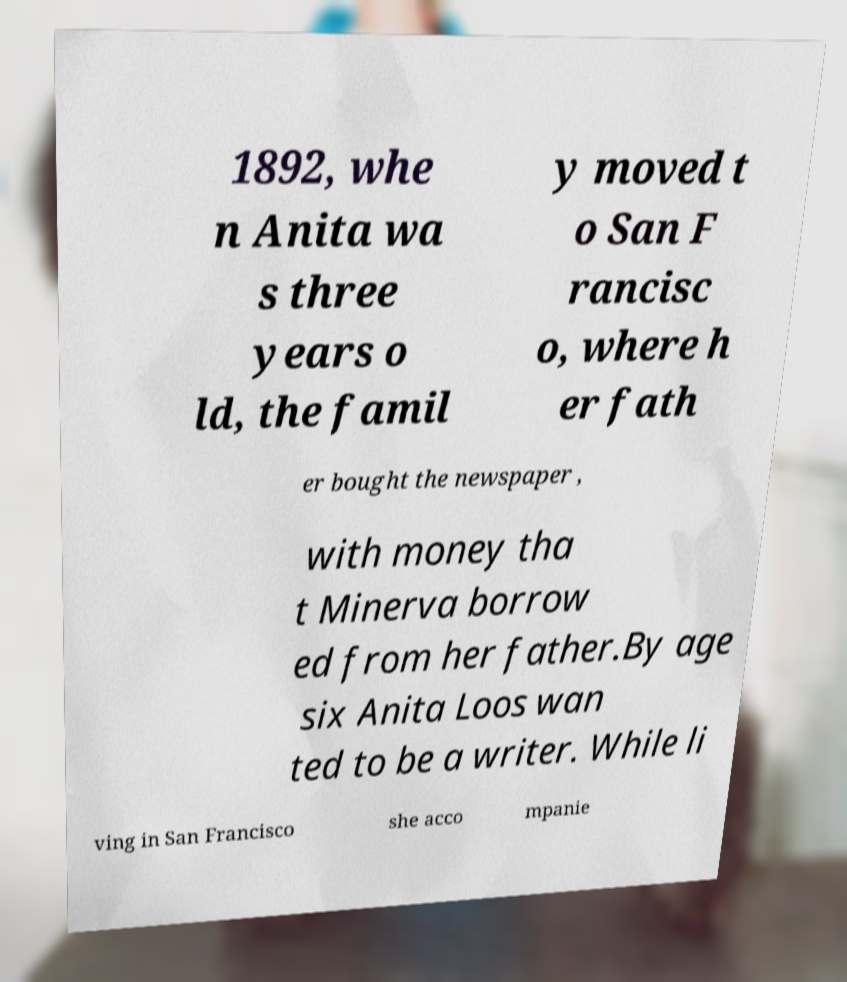Could you assist in decoding the text presented in this image and type it out clearly? 1892, whe n Anita wa s three years o ld, the famil y moved t o San F rancisc o, where h er fath er bought the newspaper , with money tha t Minerva borrow ed from her father.By age six Anita Loos wan ted to be a writer. While li ving in San Francisco she acco mpanie 